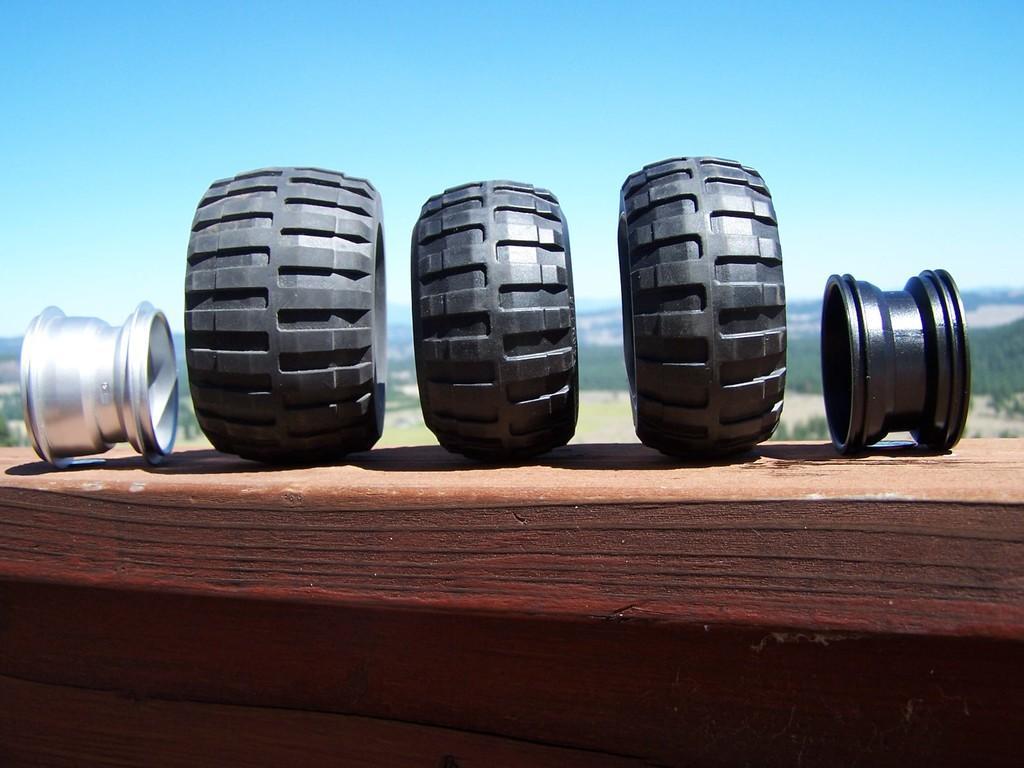In one or two sentences, can you explain what this image depicts? There are three black color tires, a silver color object and a black color object arranged on the wall. In the background, there are trees and plants on the ground and there is blue sky. 